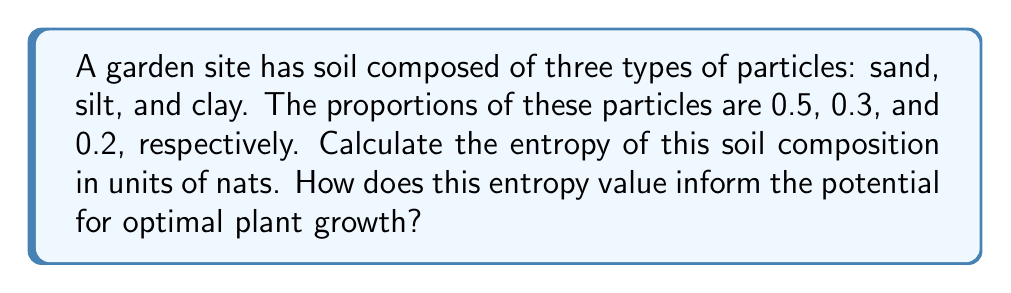What is the answer to this math problem? To calculate the entropy of the soil composition, we'll use the Shannon entropy formula:

$$S = -\sum_{i=1}^{n} p_i \ln(p_i)$$

Where:
$S$ is the entropy
$p_i$ is the proportion of each soil particle type
$n$ is the number of particle types

Step 1: Identify the probabilities (proportions) for each soil particle type:
$p_{sand} = 0.5$
$p_{silt} = 0.3$
$p_{clay} = 0.2$

Step 2: Calculate the entropy contribution of each soil particle type:

For sand: $-0.5 \ln(0.5) = 0.34657$
For silt: $-0.3 \ln(0.3) = 0.36119$
For clay: $-0.2 \ln(0.2) = 0.32189$

Step 3: Sum the individual contributions to get the total entropy:

$$S = 0.34657 + 0.36119 + 0.32189 = 1.02965 \text{ nats}$$

Interpretation for optimal plant growth:
A higher entropy value indicates a more diverse soil composition, which is generally beneficial for plant growth. The calculated entropy of 1.02965 nats suggests a relatively balanced mix of soil particles. This diversity can provide:

1. Better water retention and drainage
2. Improved nutrient holding capacity
3. Enhanced root penetration and growth

However, the optimal entropy value depends on specific plant requirements. Some plants may prefer more specialized soil compositions. As a real estate developer, this entropy value suggests that the site has potential for a variety of plants, but further analysis may be needed for specific landscaping plans.
Answer: 1.02965 nats 